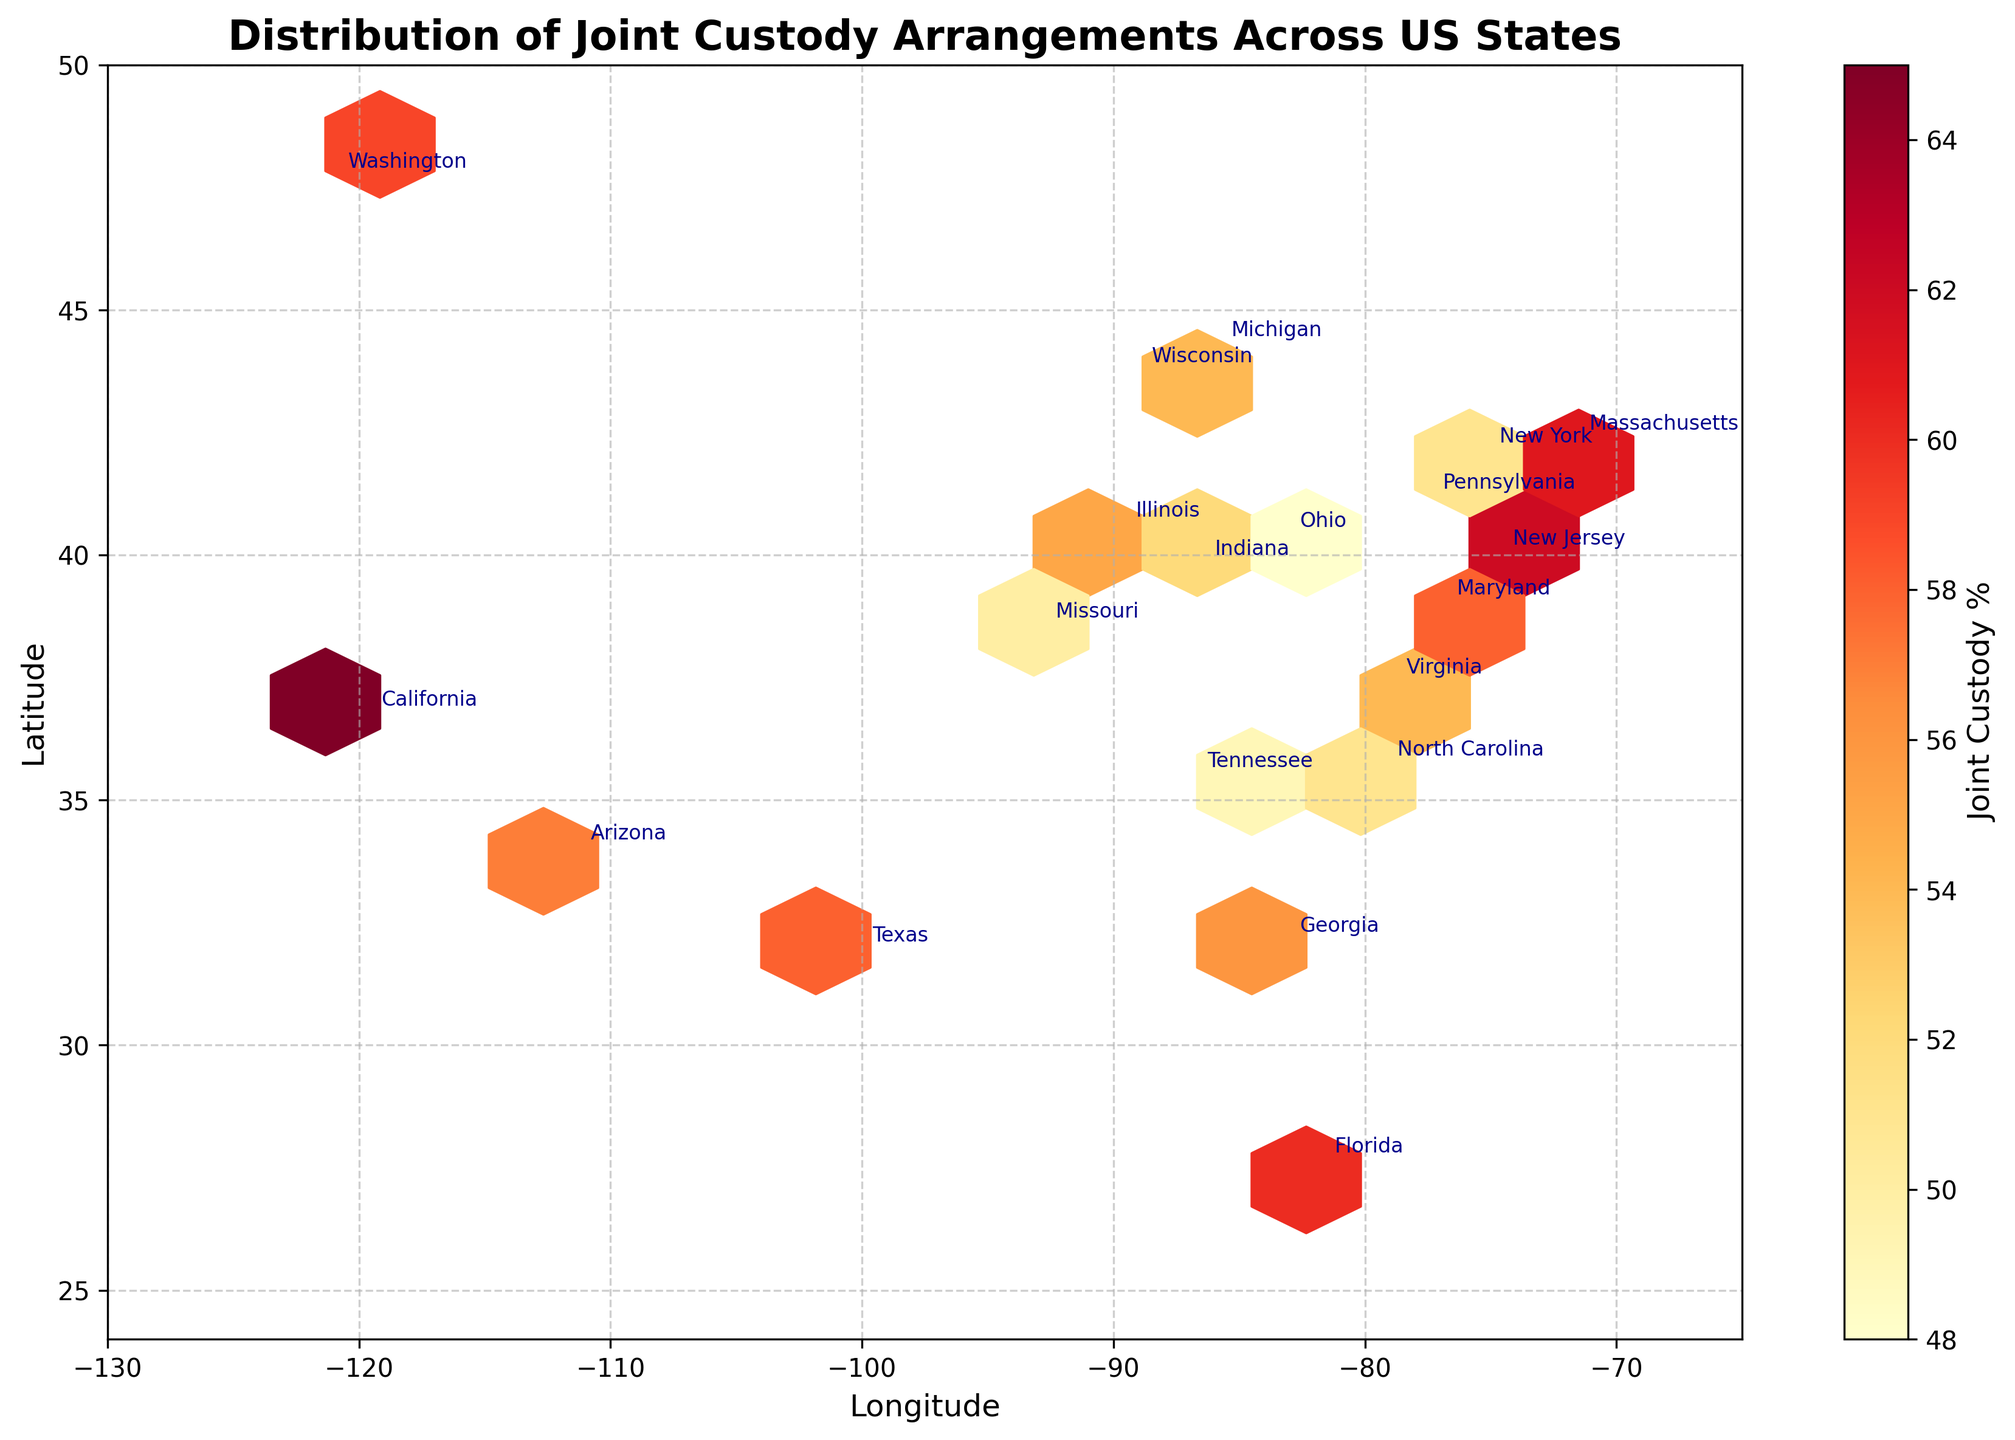Which state has the highest percentage of joint custody arrangements? By looking at the color intensity and annotations in the plot, we can identify that California is shaded the darkest, indicating the highest percentage of joint custody arrangements at 65%.
Answer: California Which state has the lowest percentage of joint custody arrangements? By examining the color intensities and annotations, Pennsylvania and Ohio show the lightest shades, indicating the lowest percentage of joint custody arrangements at 50% and 48% respectively. Among them, Ohio has a slightly lower value.
Answer: Ohio What is the general trend of joint custody arrangements across the western vs eastern states? The color intensities generally appear darker in the western states like California, Arizona, and Washington compared to eastern states like Pennsylvania and Ohio, indicating a higher percentage of joint custody arrangements in the west.
Answer: Higher in the west What is the average percentage of joint custody arrangements for the states displayed? To calculate the average percentage, sum all the joint custody percentages and divide by the number of states: (65+58+52+60+55+50+48+56+53+51+62+54+59+57+61+49+52+50+58+55)/20. This results in an average of approximately 55%.
Answer: 55% How does the joint custody percentage in Florida compare to that of New York? By comparing the annotations, Florida has 60% joint custody arrangements and New York has 52%, indicating Florida has a higher percentage of joint custody arrangements.
Answer: Higher in Florida Is there a state where the percentage of joint custody and sole custody are equal? By examining the annotations on the plot, Pennsylvania and Missouri both show 50% for both joint and sole custody arrangements, indicating equality.
Answer: Pennsylvania and Missouri Which state in the plot has a joint custody percentage closest to the mean value? The average joint custody percentage is approximately 55%. Comparing the states, New Jersey (62%), Georgia (56%), and Illinois (55%) are close, but Illinois is the exact mean value.
Answer: Illinois Are there any states with over 60% joint custody arrangements? By looking at the annotations and colors, California, New Jersey, and Massachusetts stand out with joint custody percentages of 65%, 62%, and 61% respectively.
Answer: Yes Do any states have a joint custody percentage below 50%? By examining the annotations, Ohio shows a joint custody percentage of 48%, indicating it is below 50%.
Answer: Yes, Ohio 